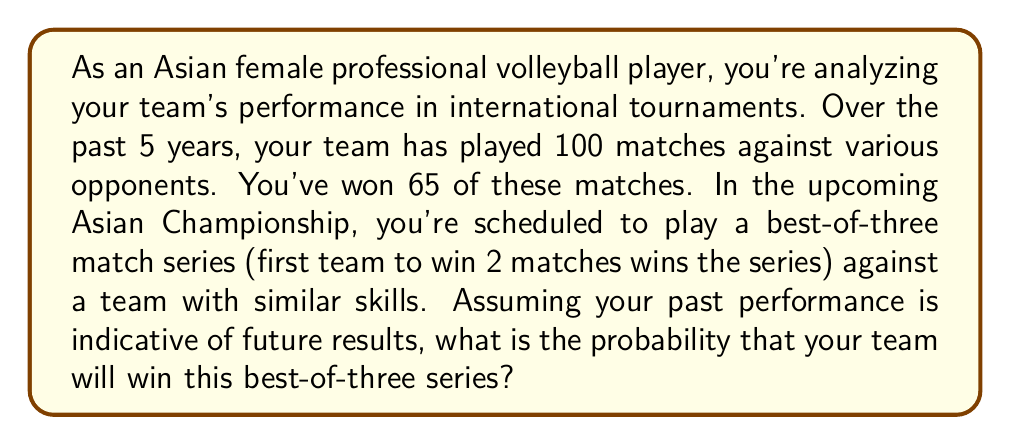Can you solve this math problem? To solve this problem, we need to follow these steps:

1. Calculate the probability of winning a single match based on historical data.
2. Determine the possible ways to win a best-of-three series.
3. Calculate the probability of each winning scenario.
4. Sum up the probabilities of all winning scenarios.

Step 1: Probability of winning a single match
Based on historical data:
$P(\text{win single match}) = \frac{\text{Number of wins}}{\text{Total matches}} = \frac{65}{100} = 0.65$

Step 2: Possible ways to win a best-of-three series
- Win first two matches (WW)
- Win first and third matches (WLW)
- Win second and third matches (LWW)

Step 3: Probability of each winning scenario
Let $p = 0.65$ (probability of winning a single match)

a) P(WW) = $p \cdot p = 0.65 \cdot 0.65 = 0.4225$

b) P(WLW) = $p \cdot (1-p) \cdot p = 0.65 \cdot 0.35 \cdot 0.65 = 0.148525$

c) P(LWW) = $(1-p) \cdot p \cdot p = 0.35 \cdot 0.65 \cdot 0.65 = 0.148525$

Step 4: Sum up the probabilities of all winning scenarios
$P(\text{win series}) = P(WW) + P(WLW) + P(LWW)$

$P(\text{win series}) = 0.4225 + 0.148525 + 0.148525 = 0.71955$

Therefore, the probability of winning the best-of-three series is approximately 0.71955 or 71.955%.
Answer: The probability that your team will win the best-of-three series is approximately 0.71955 or 71.955%. 